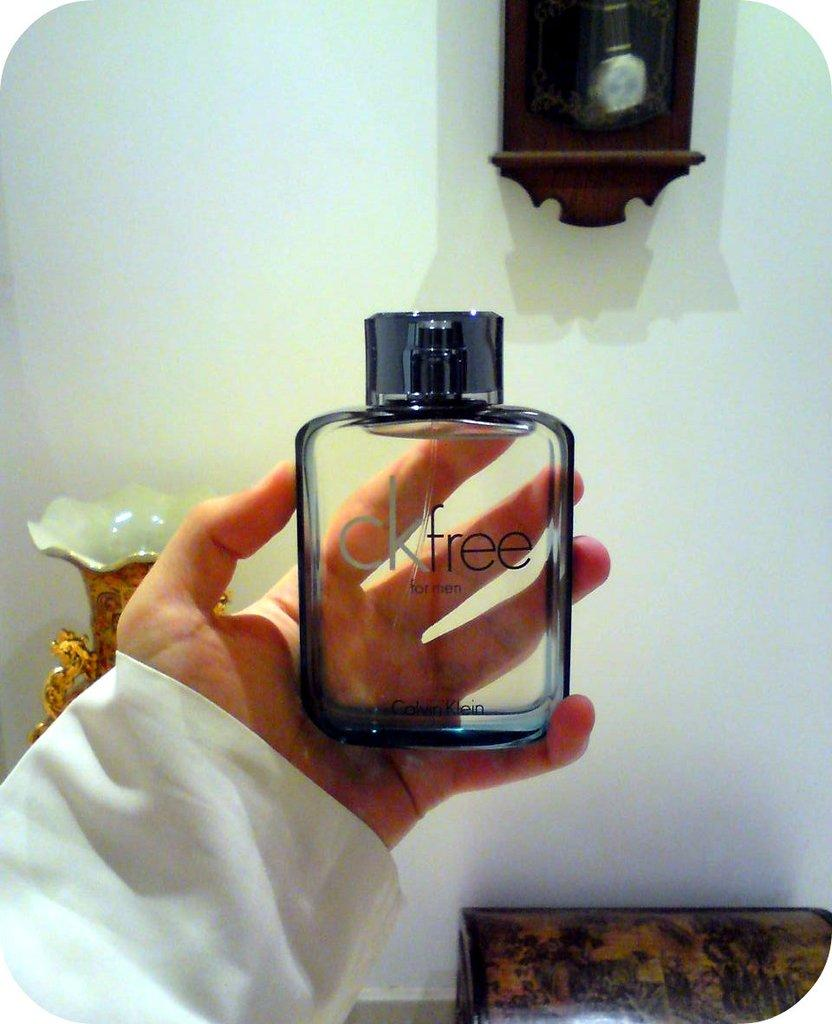What is the person in the image holding? The person is holding a glass bottle in the image. What can be seen behind the person? There is a vase behind the person. What color is the wall in the image? The wall is white. What time-keeping device is attached to the wall? There is a clock attached to the wall. How does the person in the image increase the size of the comb? There is no comb present in the image, so it cannot be increased in size. 